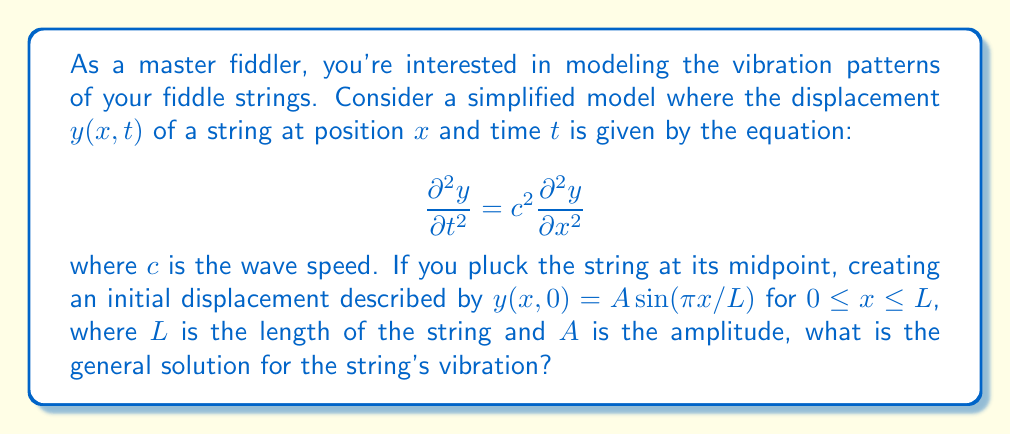Teach me how to tackle this problem. Let's approach this step-by-step:

1) The given partial differential equation is the wave equation. For a plucked string, we can use the method of separation of variables.

2) Assume a solution of the form $y(x,t) = X(x)T(t)$.

3) Substituting this into the wave equation:

   $$X(x)\frac{d^2T}{dt^2} = c^2T(t)\frac{d^2X}{dx^2}$$

4) Dividing both sides by $c^2X(x)T(t)$:

   $$\frac{1}{c^2T}\frac{d^2T}{dt^2} = \frac{1}{X}\frac{d^2X}{dx^2}$$

5) Since the left side depends only on $t$ and the right side only on $x$, both must equal a constant. Let's call this constant $-k^2$:

   $$\frac{d^2T}{dt^2} + k^2c^2T = 0$$
   $$\frac{d^2X}{dx^2} + k^2X = 0$$

6) The general solutions to these equations are:

   $$T(t) = a \cos(kct) + b \sin(kct)$$
   $$X(x) = C \sin(kx) + D \cos(kx)$$

7) Given the boundary conditions (fixed ends), $X(0) = X(L) = 0$, we find that $D = 0$ and $k = n\pi/L$ for $n = 1, 2, 3, ...$

8) Therefore, the general solution is:

   $$y(x,t) = \sum_{n=1}^{\infty} (A_n \cos(n\pi ct/L) + B_n \sin(n\pi ct/L)) \sin(n\pi x/L)$$

9) The initial condition $y(x,0) = A \sin(\pi x/L)$ corresponds to the first mode $(n=1)$ of vibration.

10) Comparing this with our general solution at $t=0$:

    $$A \sin(\pi x/L) = A_1 \sin(\pi x/L)$$

    We see that $A_1 = A$ and all other $A_n = 0$.

11) The initial velocity is zero, so $B_n = 0$ for all $n$.

Therefore, the specific solution for this plucked string is:

$$y(x,t) = A \cos(\pi ct/L) \sin(\pi x/L)$$
Answer: $y(x,t) = A \cos(\pi ct/L) \sin(\pi x/L)$ 